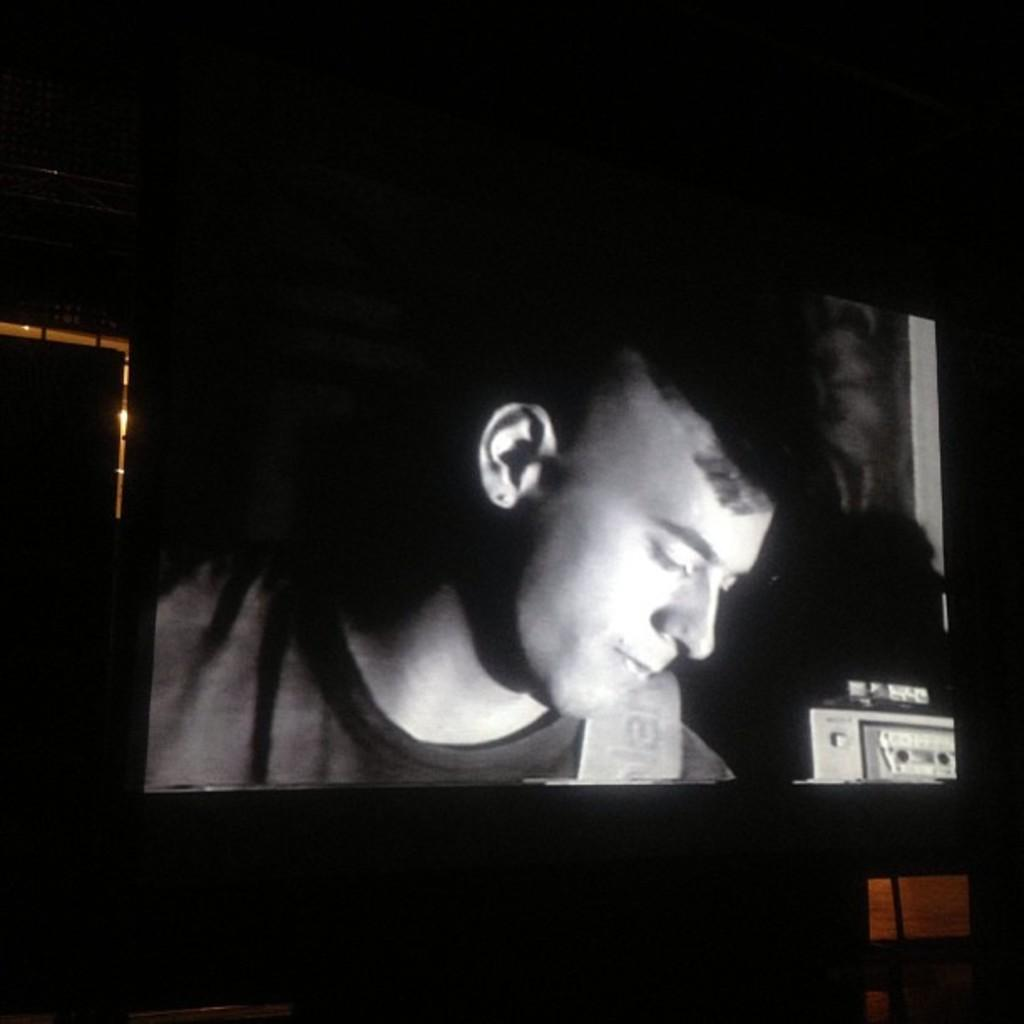What is located on the right side of the image? There is an object on the right side of the image. What can be seen on the screen in the image? There is a man visible on a screen in the image. How would you describe the background of the image? The background of the image has a dark view. How many children are playing with the invention in the image? There are no children or inventions present in the image. What is the story behind the man on the screen in the image? The image does not provide any information about a story behind the man on the screen. 